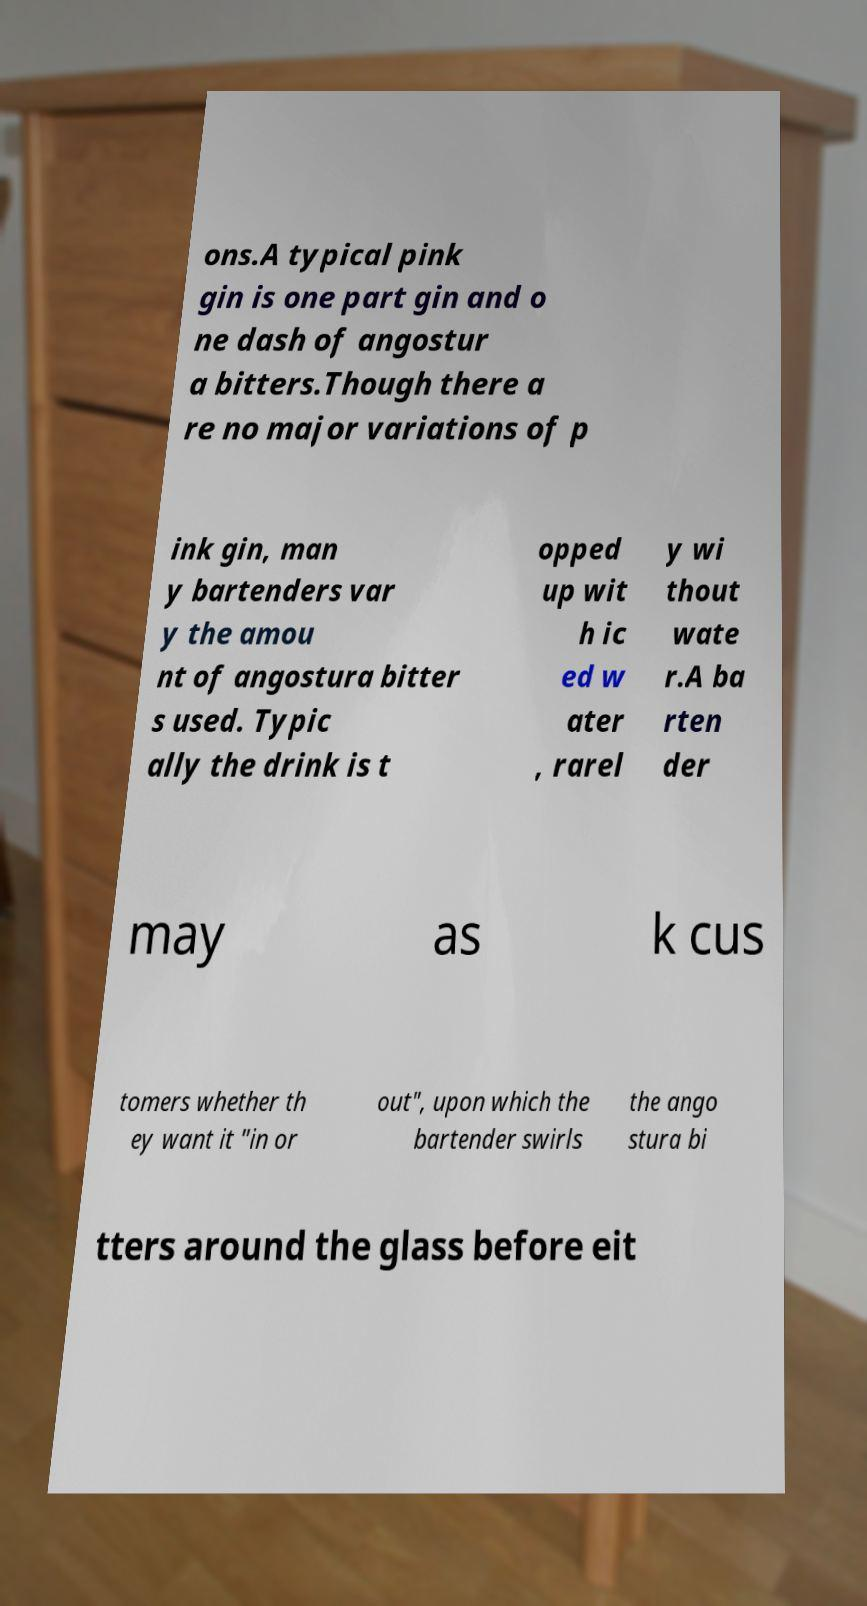For documentation purposes, I need the text within this image transcribed. Could you provide that? ons.A typical pink gin is one part gin and o ne dash of angostur a bitters.Though there a re no major variations of p ink gin, man y bartenders var y the amou nt of angostura bitter s used. Typic ally the drink is t opped up wit h ic ed w ater , rarel y wi thout wate r.A ba rten der may as k cus tomers whether th ey want it "in or out", upon which the bartender swirls the ango stura bi tters around the glass before eit 